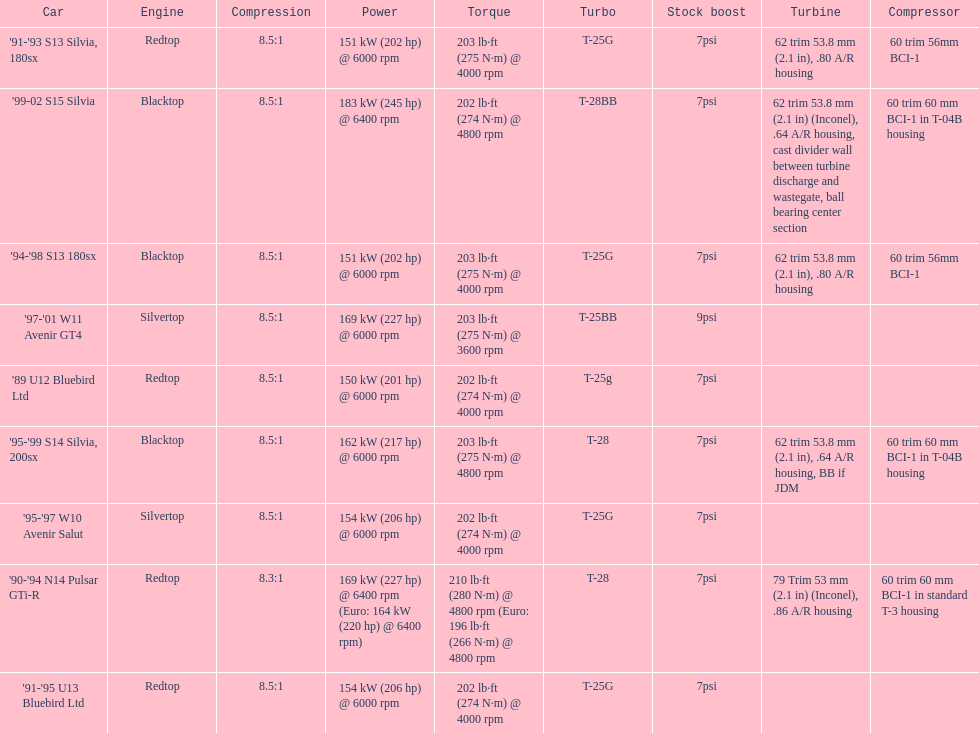Which engines are the same as the first entry ('89 u12 bluebird ltd)? '91-'95 U13 Bluebird Ltd, '90-'94 N14 Pulsar GTi-R, '91-'93 S13 Silvia, 180sx. 